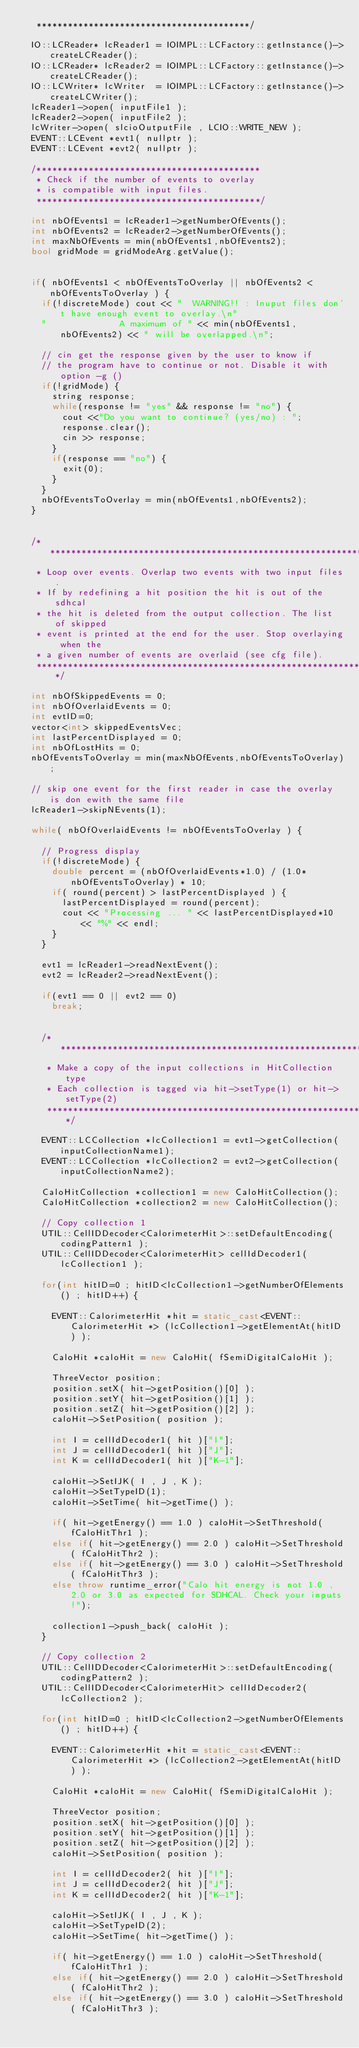Convert code to text. <code><loc_0><loc_0><loc_500><loc_500><_C++_>	 *****************************************/

	IO::LCReader* lcReader1 = IOIMPL::LCFactory::getInstance()->createLCReader();
	IO::LCReader* lcReader2 = IOIMPL::LCFactory::getInstance()->createLCReader();
	IO::LCWriter* lcWriter  = IOIMPL::LCFactory::getInstance()->createLCWriter();
	lcReader1->open( inputFile1 );
	lcReader2->open( inputFile2 );
	lcWriter->open( slcioOutputFile , LCIO::WRITE_NEW );
	EVENT::LCEvent *evt1( nullptr );
	EVENT::LCEvent *evt2( nullptr );

	/*******************************************
	 * Check if the number of events to overlay
	 * is compatible with input files.
	 *******************************************/

	int nbOfEvents1 = lcReader1->getNumberOfEvents();
	int nbOfEvents2 = lcReader2->getNumberOfEvents();
	int maxNbOfEvents = min(nbOfEvents1,nbOfEvents2);
	bool gridMode = gridModeArg.getValue();


	if( nbOfEvents1 < nbOfEventsToOverlay || nbOfEvents2 < nbOfEventsToOverlay ) {
		if(!discreteMode) cout << "  WARNING!! : Inuput files don't have enough event to overlay.\n"
		"              A maximum of " << min(nbOfEvents1,nbOfEvents2) << " will be overlapped.\n";

		// cin get the response given by the user to know if
		// the program have to continue or not. Disable it with option -g ()
		if(!gridMode) {
			string response;
			while(response != "yes" && response != "no") {
				cout <<"Do you want to continue? (yes/no) : ";
				response.clear();
				cin >> response;
			}
			if(response == "no") {
				exit(0);
			}
		}
		nbOfEventsToOverlay = min(nbOfEvents1,nbOfEvents2);
	}


	/********************************************************************
	 * Loop over events. Overlap two events with two input files.
	 * If by redefining a hit position the hit is out of the sdhcal
	 * the hit is deleted from the output collection. The list of skipped
	 * event is printed at the end for the user. Stop overlaying when the
	 * a given number of events are overlaid (see cfg file).
	 ********************************************************************/

	int nbOfSkippedEvents = 0;
	int nbOfOverlaidEvents = 0;
	int evtID=0;
	vector<int> skippedEventsVec;
	int lastPercentDisplayed = 0;
	int nbOfLostHits = 0;
	nbOfEventsToOverlay = min(maxNbOfEvents,nbOfEventsToOverlay);

	// skip one event for the first reader in case the overlay is don ewith the same file
	lcReader1->skipNEvents(1);

	while( nbOfOverlaidEvents != nbOfEventsToOverlay ) {

		// Progress display
		if(!discreteMode) {
			double percent = (nbOfOverlaidEvents*1.0) / (1.0*nbOfEventsToOverlay) * 10;
			if( round(percent) > lastPercentDisplayed ) {
				lastPercentDisplayed = round(percent);
				cout << "Processing ... " << lastPercentDisplayed*10 << "%" << endl;
			}
		}

		evt1 = lcReader1->readNextEvent();
		evt2 = lcReader2->readNextEvent();

		if(evt1 == 0 || evt2 == 0)
			break;


		/*****************************************************************
		 * Make a copy of the input collections in HitCollection type
		 * Each collection is tagged via hit->setType(1) or hit->setType(2)
		 ******************************************************************/

		EVENT::LCCollection *lcCollection1 = evt1->getCollection(inputCollectionName1);
		EVENT::LCCollection *lcCollection2 = evt2->getCollection(inputCollectionName2);

		CaloHitCollection *collection1 = new CaloHitCollection();
		CaloHitCollection *collection2 = new CaloHitCollection();

		// Copy collection 1
		UTIL::CellIDDecoder<CalorimeterHit>::setDefaultEncoding( codingPattern1 );
		UTIL::CellIDDecoder<CalorimeterHit> cellIdDecoder1( lcCollection1 );

		for(int hitID=0 ; hitID<lcCollection1->getNumberOfElements() ; hitID++) {

			EVENT::CalorimeterHit *hit = static_cast<EVENT::CalorimeterHit *> (lcCollection1->getElementAt(hitID) );

			CaloHit *caloHit = new CaloHit( fSemiDigitalCaloHit );

			ThreeVector position;
			position.setX( hit->getPosition()[0] );
			position.setY( hit->getPosition()[1] );
			position.setZ( hit->getPosition()[2] );
			caloHit->SetPosition( position );

			int I = cellIdDecoder1( hit )["I"];
			int J = cellIdDecoder1( hit )["J"];
			int K = cellIdDecoder1( hit )["K-1"];

			caloHit->SetIJK( I , J , K );
			caloHit->SetTypeID(1);
			caloHit->SetTime( hit->getTime() );

			if( hit->getEnergy() == 1.0 ) caloHit->SetThreshold( fCaloHitThr1 );
			else if( hit->getEnergy() == 2.0 ) caloHit->SetThreshold( fCaloHitThr2 );
			else if( hit->getEnergy() == 3.0 ) caloHit->SetThreshold( fCaloHitThr3 );
			else throw runtime_error("Calo hit energy is not 1.0 , 2.0 or 3.0 as expected for SDHCAL. Check your inputs!");

			collection1->push_back( caloHit );
		}

		// Copy collection 2
		UTIL::CellIDDecoder<CalorimeterHit>::setDefaultEncoding( codingPattern2 );
		UTIL::CellIDDecoder<CalorimeterHit> cellIdDecoder2( lcCollection2 );

		for(int hitID=0 ; hitID<lcCollection2->getNumberOfElements() ; hitID++) {

			EVENT::CalorimeterHit *hit = static_cast<EVENT::CalorimeterHit *> (lcCollection2->getElementAt(hitID) );

			CaloHit *caloHit = new CaloHit( fSemiDigitalCaloHit );

			ThreeVector position;
			position.setX( hit->getPosition()[0] );
			position.setY( hit->getPosition()[1] );
			position.setZ( hit->getPosition()[2] );
			caloHit->SetPosition( position );

			int I = cellIdDecoder2( hit )["I"];
			int J = cellIdDecoder2( hit )["J"];
			int K = cellIdDecoder2( hit )["K-1"];

			caloHit->SetIJK( I , J , K );
			caloHit->SetTypeID(2);
			caloHit->SetTime( hit->getTime() );

			if( hit->getEnergy() == 1.0 ) caloHit->SetThreshold( fCaloHitThr1 );
			else if( hit->getEnergy() == 2.0 ) caloHit->SetThreshold( fCaloHitThr2 );
			else if( hit->getEnergy() == 3.0 ) caloHit->SetThreshold( fCaloHitThr3 );</code> 